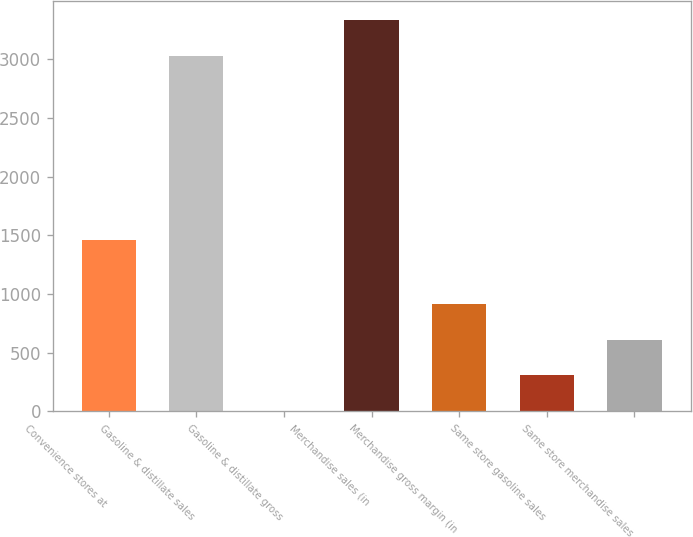<chart> <loc_0><loc_0><loc_500><loc_500><bar_chart><fcel>Convenience stores at<fcel>Gasoline & distillate sales<fcel>Gasoline & distillate gross<fcel>Merchandise sales (in<fcel>Merchandise gross margin (in<fcel>Same store gasoline sales<fcel>Same store merchandise sales<nl><fcel>1464<fcel>3027<fcel>0.13<fcel>3332.79<fcel>917.5<fcel>305.92<fcel>611.71<nl></chart> 